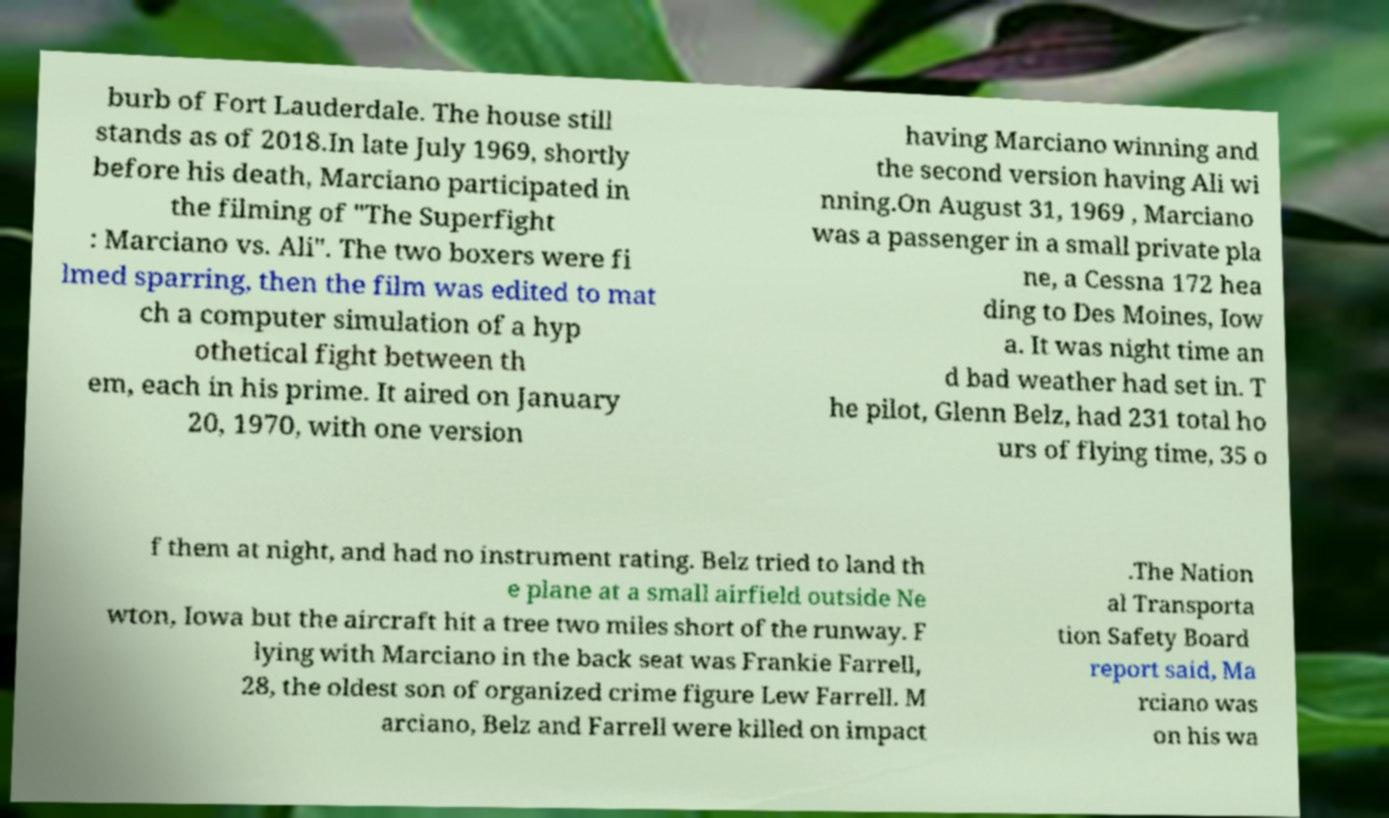For documentation purposes, I need the text within this image transcribed. Could you provide that? burb of Fort Lauderdale. The house still stands as of 2018.In late July 1969, shortly before his death, Marciano participated in the filming of "The Superfight : Marciano vs. Ali". The two boxers were fi lmed sparring, then the film was edited to mat ch a computer simulation of a hyp othetical fight between th em, each in his prime. It aired on January 20, 1970, with one version having Marciano winning and the second version having Ali wi nning.On August 31, 1969 , Marciano was a passenger in a small private pla ne, a Cessna 172 hea ding to Des Moines, Iow a. It was night time an d bad weather had set in. T he pilot, Glenn Belz, had 231 total ho urs of flying time, 35 o f them at night, and had no instrument rating. Belz tried to land th e plane at a small airfield outside Ne wton, Iowa but the aircraft hit a tree two miles short of the runway. F lying with Marciano in the back seat was Frankie Farrell, 28, the oldest son of organized crime figure Lew Farrell. M arciano, Belz and Farrell were killed on impact .The Nation al Transporta tion Safety Board report said, Ma rciano was on his wa 